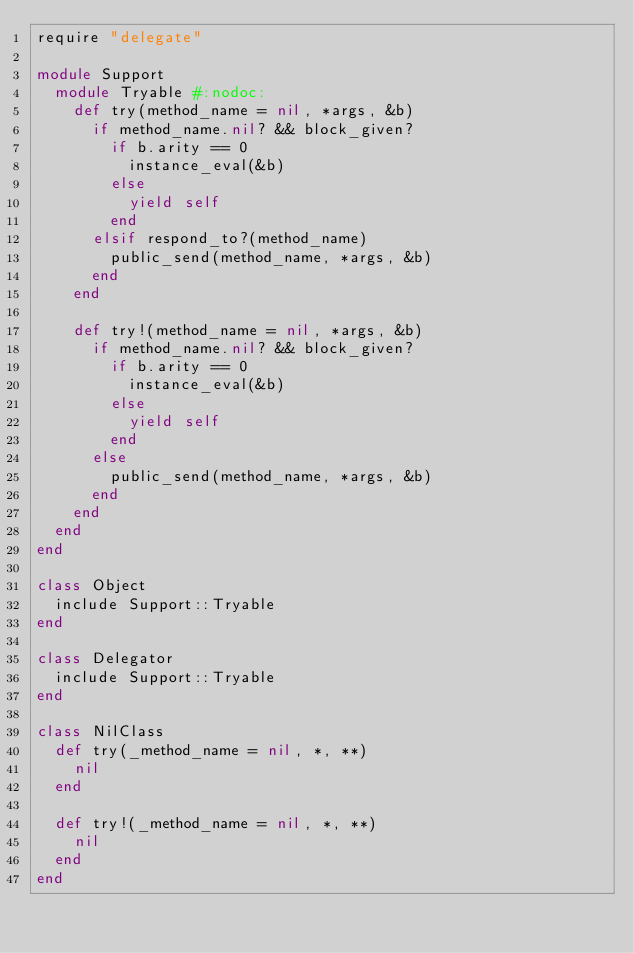Convert code to text. <code><loc_0><loc_0><loc_500><loc_500><_Ruby_>require "delegate"

module Support
  module Tryable #:nodoc:
    def try(method_name = nil, *args, &b)
      if method_name.nil? && block_given?
        if b.arity == 0
          instance_eval(&b)
        else
          yield self
        end
      elsif respond_to?(method_name)
        public_send(method_name, *args, &b)
      end
    end

    def try!(method_name = nil, *args, &b)
      if method_name.nil? && block_given?
        if b.arity == 0
          instance_eval(&b)
        else
          yield self
        end
      else
        public_send(method_name, *args, &b)
      end
    end
  end
end

class Object
  include Support::Tryable
end

class Delegator
  include Support::Tryable
end

class NilClass
  def try(_method_name = nil, *, **)
    nil
  end

  def try!(_method_name = nil, *, **)
    nil
  end
end
</code> 